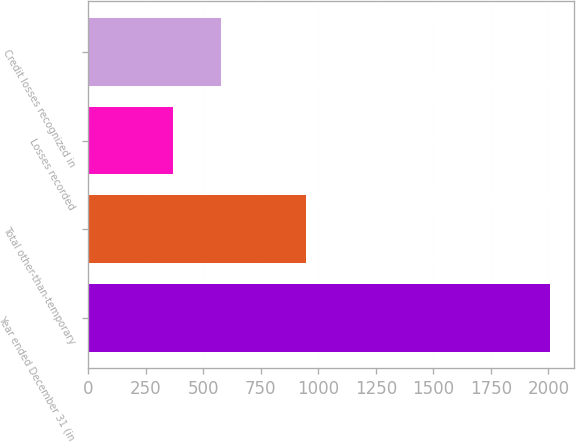<chart> <loc_0><loc_0><loc_500><loc_500><bar_chart><fcel>Year ended December 31 (in<fcel>Total other-than-temporary<fcel>Losses recorded<fcel>Credit losses recognized in<nl><fcel>2009<fcel>946<fcel>368<fcel>578<nl></chart> 